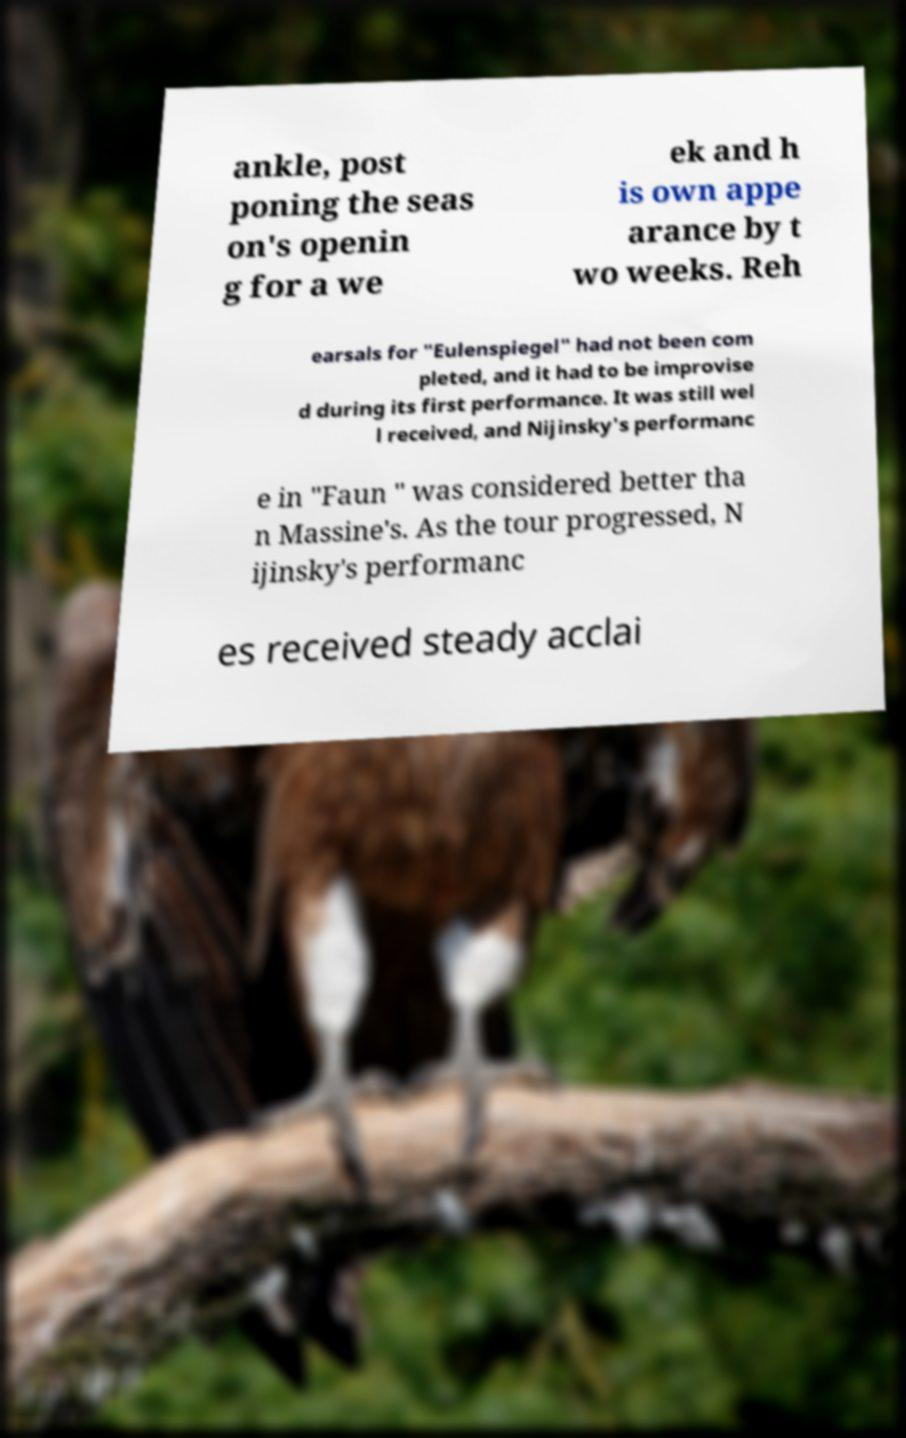What messages or text are displayed in this image? I need them in a readable, typed format. ankle, post poning the seas on's openin g for a we ek and h is own appe arance by t wo weeks. Reh earsals for "Eulenspiegel" had not been com pleted, and it had to be improvise d during its first performance. It was still wel l received, and Nijinsky's performanc e in "Faun " was considered better tha n Massine's. As the tour progressed, N ijinsky's performanc es received steady acclai 